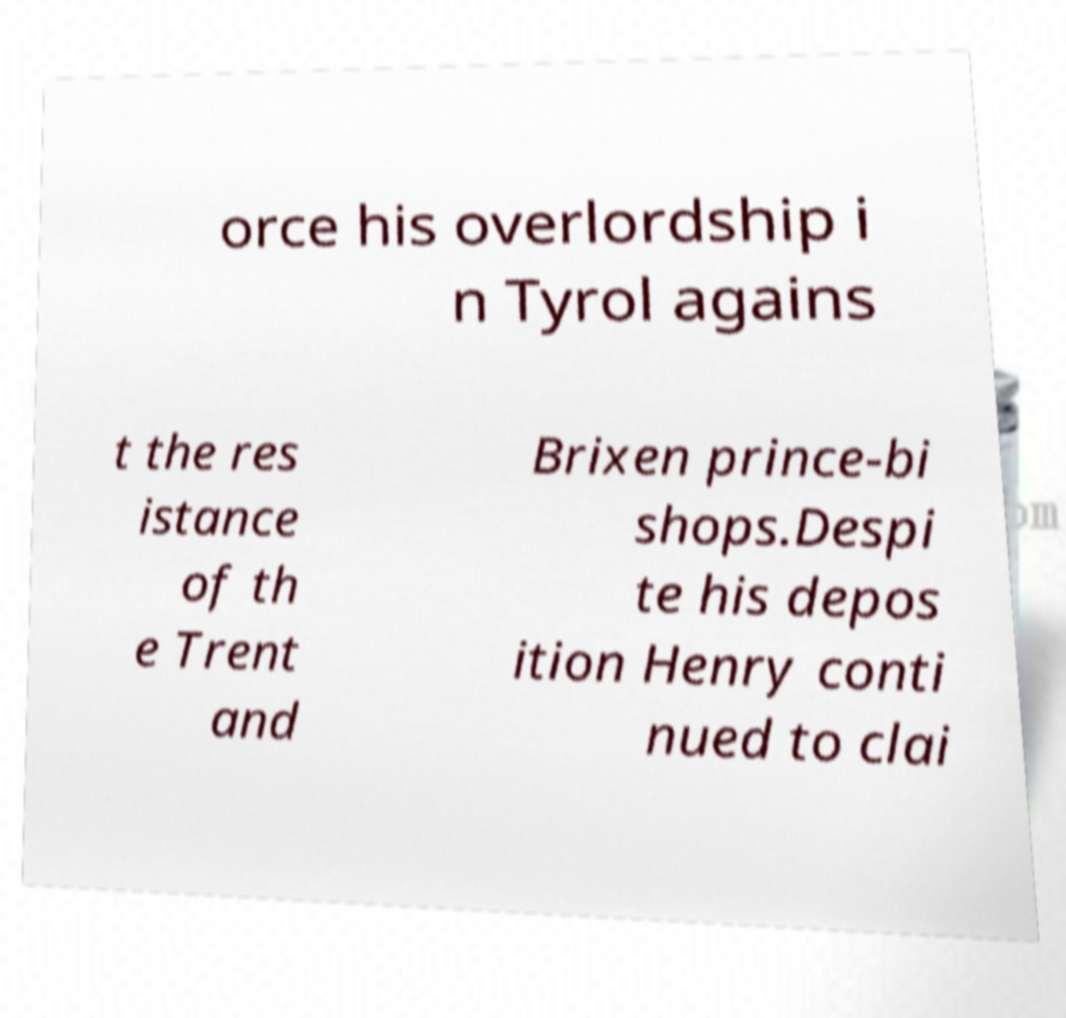Could you extract and type out the text from this image? orce his overlordship i n Tyrol agains t the res istance of th e Trent and Brixen prince-bi shops.Despi te his depos ition Henry conti nued to clai 